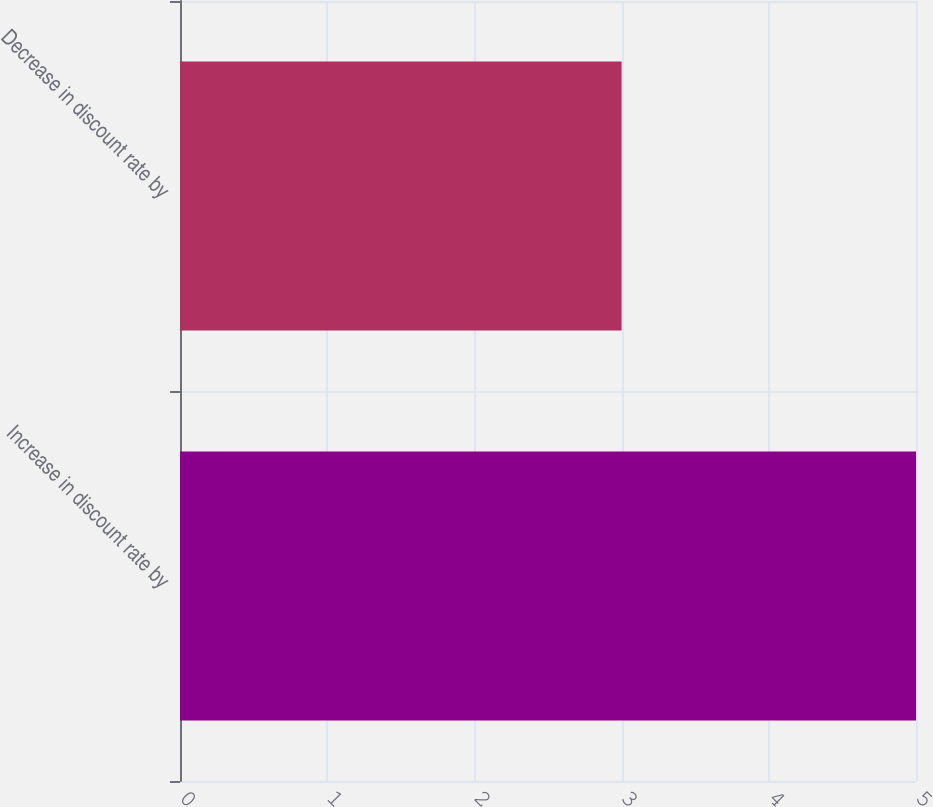Convert chart. <chart><loc_0><loc_0><loc_500><loc_500><bar_chart><fcel>Increase in discount rate by<fcel>Decrease in discount rate by<nl><fcel>5<fcel>3<nl></chart> 